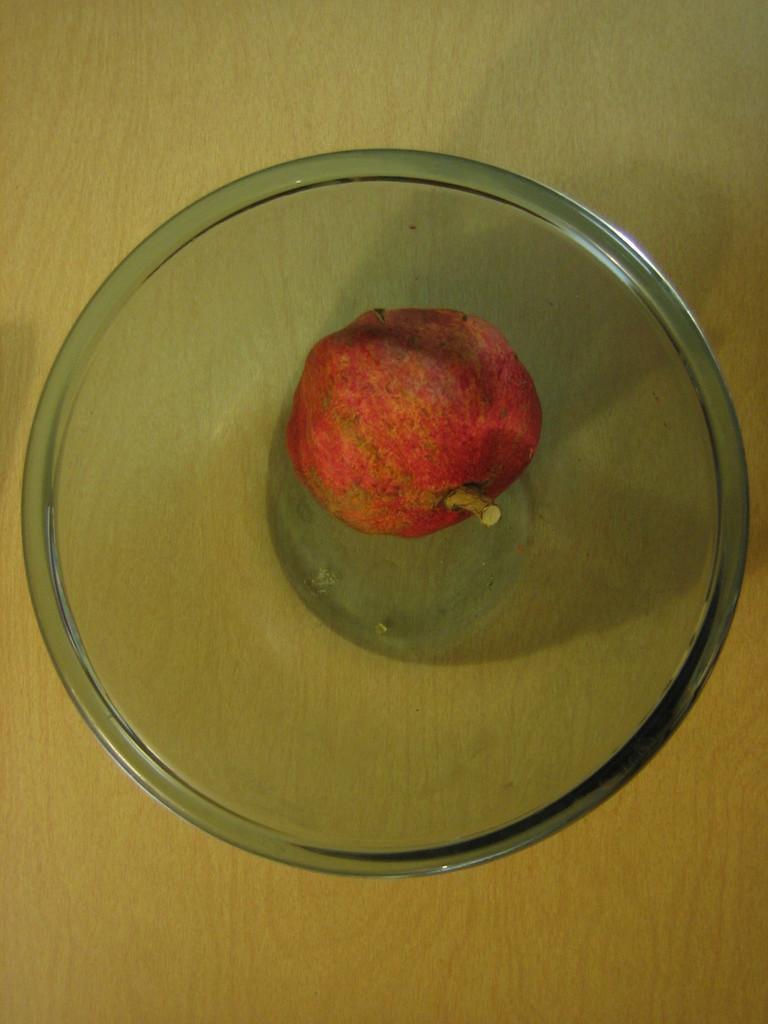Could you give a brief overview of what you see in this image? In this image there is a bowl having a fruit in it. Bowl is kept on a wooden plank. 